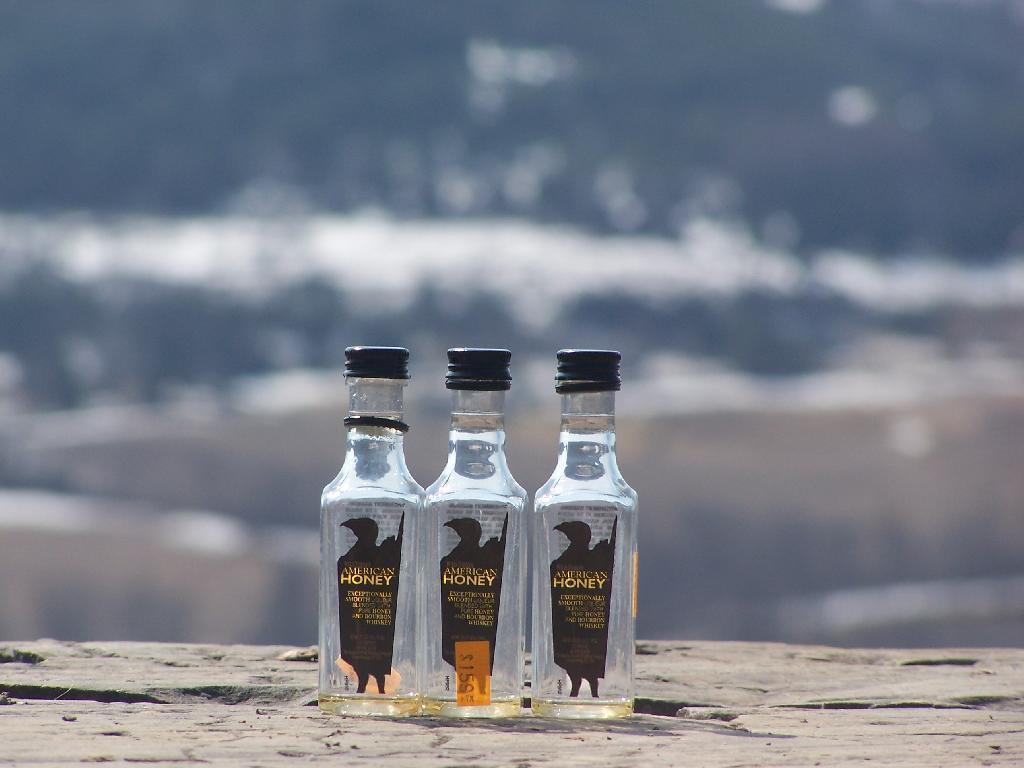What is the name of this drink?
Offer a very short reply. American honey. 